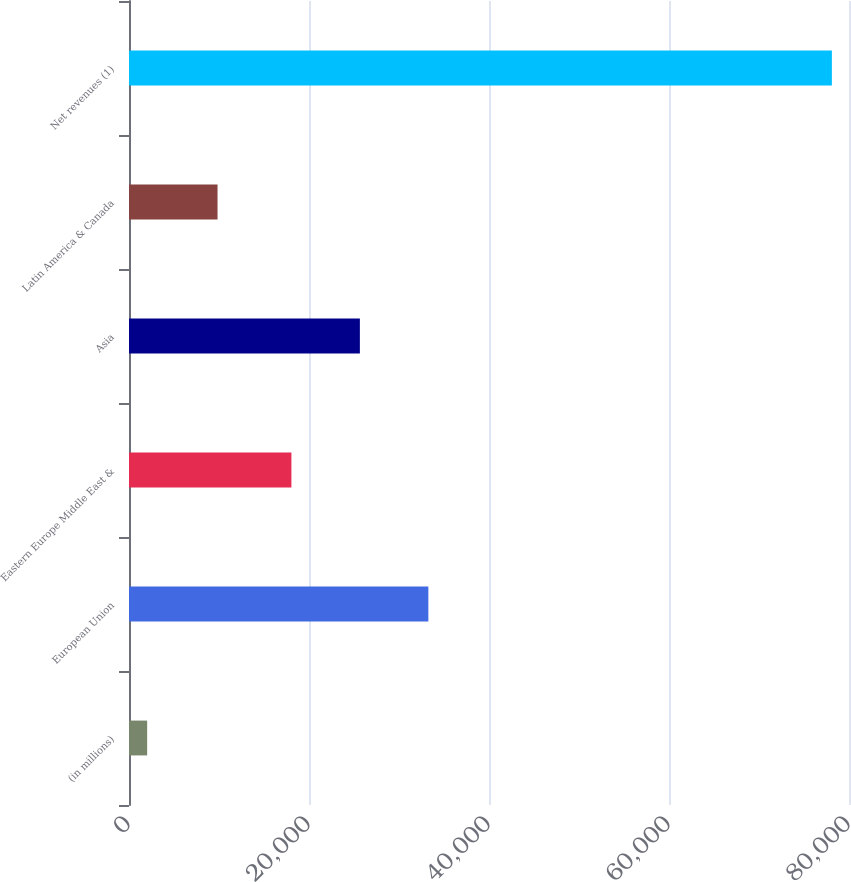Convert chart. <chart><loc_0><loc_0><loc_500><loc_500><bar_chart><fcel>(in millions)<fcel>European Union<fcel>Eastern Europe Middle East &<fcel>Asia<fcel>Latin America & Canada<fcel>Net revenues (1)<nl><fcel>2017<fcel>33261.2<fcel>18045<fcel>25653.1<fcel>9838<fcel>78098<nl></chart> 